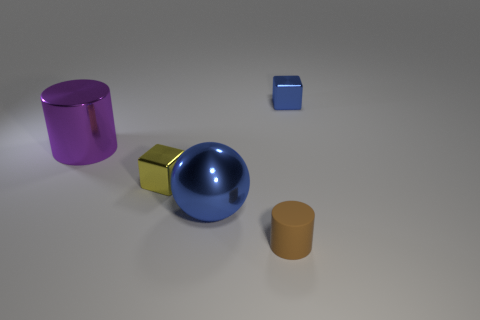Is the blue block made of the same material as the brown thing? Upon observing the image, the blue block appears to have a matte finish and could be made of plastic or a composite material, while the brown object seems to have a slightly reflective surface, suggesting that it might be made of a different type of plastic or even metal. Therefore, based on the discrepancy in their surface properties, it is unlikely that they are made of the exact same material. 